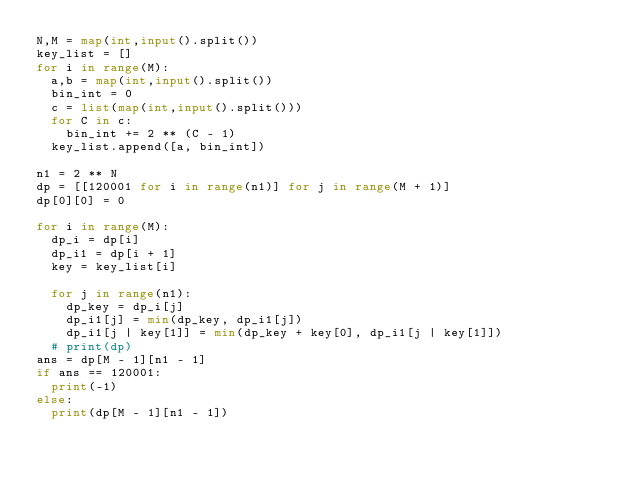<code> <loc_0><loc_0><loc_500><loc_500><_Python_>N,M = map(int,input().split())
key_list = []
for i in range(M):
  a,b = map(int,input().split())
  bin_int = 0
  c = list(map(int,input().split()))
  for C in c:
    bin_int += 2 ** (C - 1)
  key_list.append([a, bin_int])

n1 = 2 ** N
dp = [[120001 for i in range(n1)] for j in range(M + 1)]
dp[0][0] = 0

for i in range(M):
  dp_i = dp[i]
  dp_i1 = dp[i + 1]
  key = key_list[i]

  for j in range(n1):
    dp_key = dp_i[j]
    dp_i1[j] = min(dp_key, dp_i1[j])
    dp_i1[j | key[1]] = min(dp_key + key[0], dp_i1[j | key[1]])
  # print(dp)
ans = dp[M - 1][n1 - 1]
if ans == 120001:
  print(-1)
else:
  print(dp[M - 1][n1 - 1])</code> 